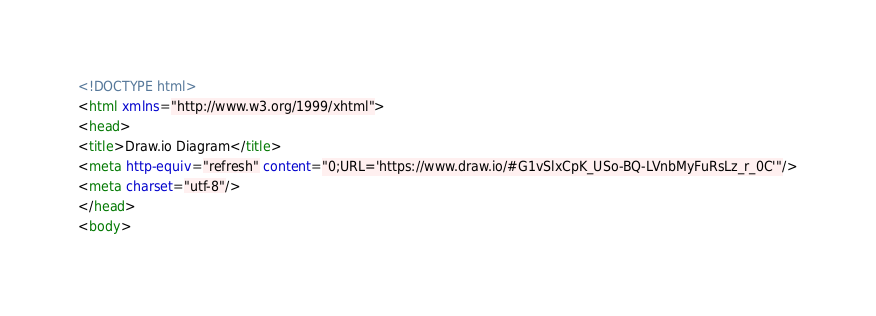<code> <loc_0><loc_0><loc_500><loc_500><_HTML_><!DOCTYPE html>
<html xmlns="http://www.w3.org/1999/xhtml">
<head>
<title>Draw.io Diagram</title>
<meta http-equiv="refresh" content="0;URL='https://www.draw.io/#G1vSlxCpK_USo-BQ-LVnbMyFuRsLz_r_0C'"/>
<meta charset="utf-8"/>
</head>
<body></code> 